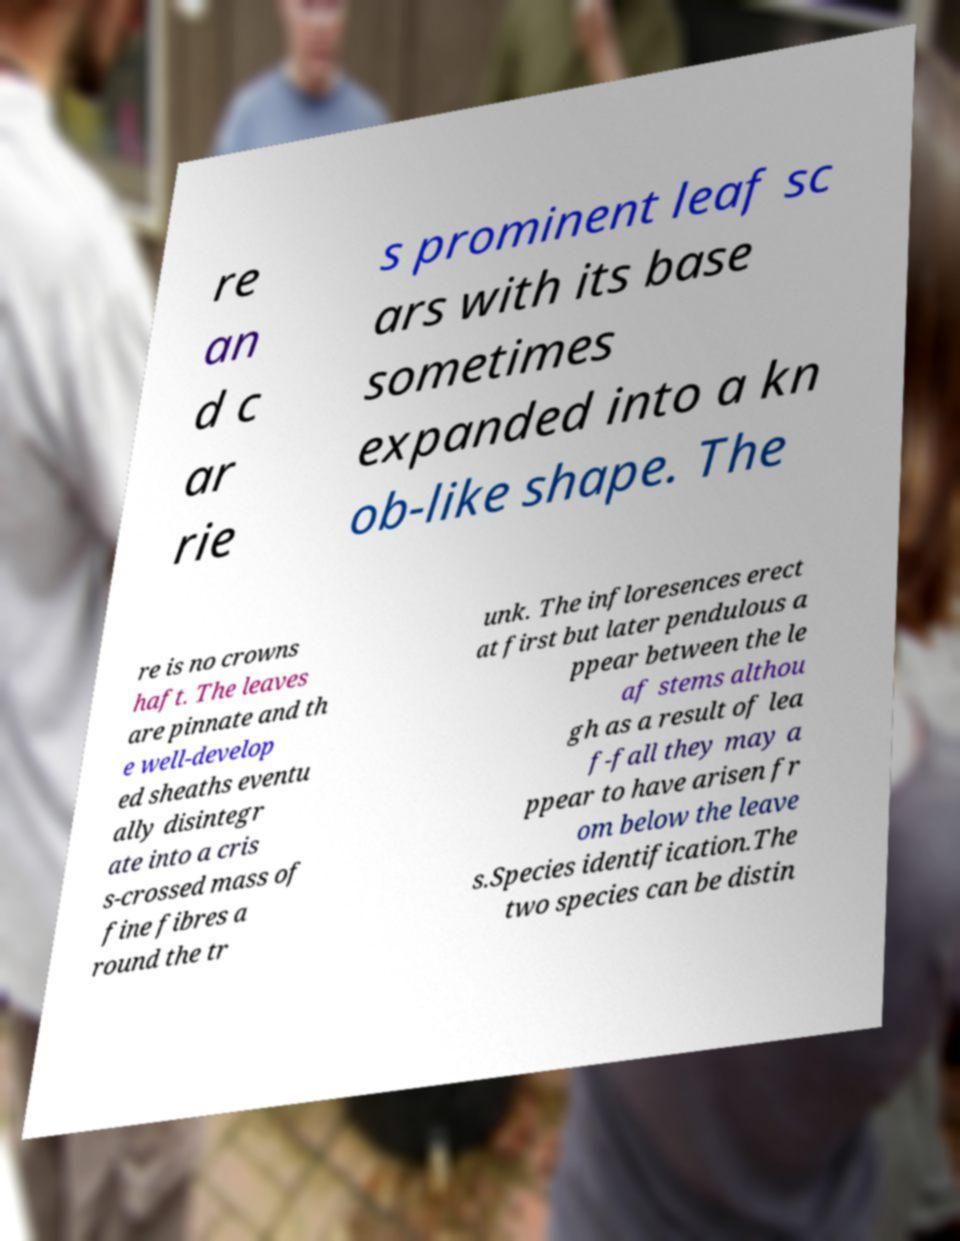I need the written content from this picture converted into text. Can you do that? re an d c ar rie s prominent leaf sc ars with its base sometimes expanded into a kn ob-like shape. The re is no crowns haft. The leaves are pinnate and th e well-develop ed sheaths eventu ally disintegr ate into a cris s-crossed mass of fine fibres a round the tr unk. The infloresences erect at first but later pendulous a ppear between the le af stems althou gh as a result of lea f-fall they may a ppear to have arisen fr om below the leave s.Species identification.The two species can be distin 